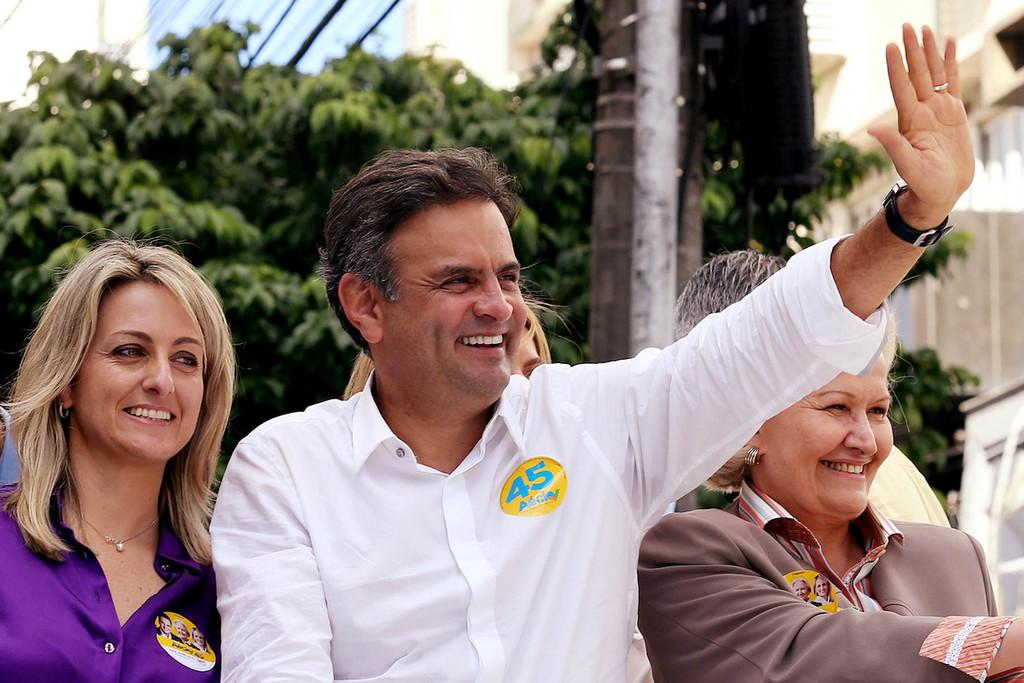What is the main subject in the foreground of the image? There is a group of people in the foreground of the image. What can be seen in the background of the image? There are buildings, cables, and trees in the background of the image. What type of vessel is being used by the people in the image? There is no vessel present in the image; it only shows a group of people and the background. 